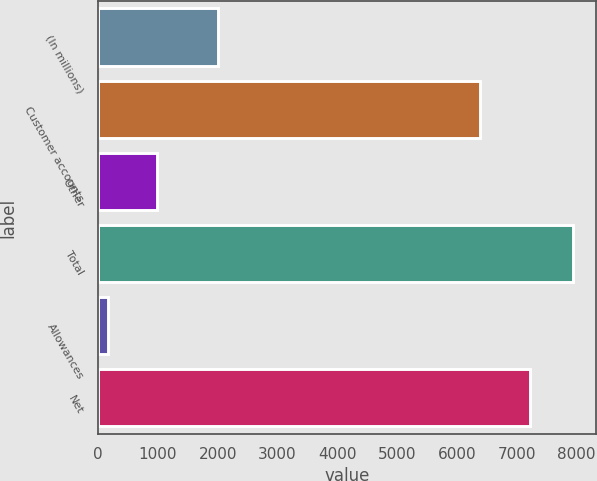<chart> <loc_0><loc_0><loc_500><loc_500><bar_chart><fcel>(In millions)<fcel>Customer accounts<fcel>Other<fcel>Total<fcel>Allowances<fcel>Net<nl><fcel>2008<fcel>6390<fcel>984<fcel>7934.3<fcel>161<fcel>7213<nl></chart> 